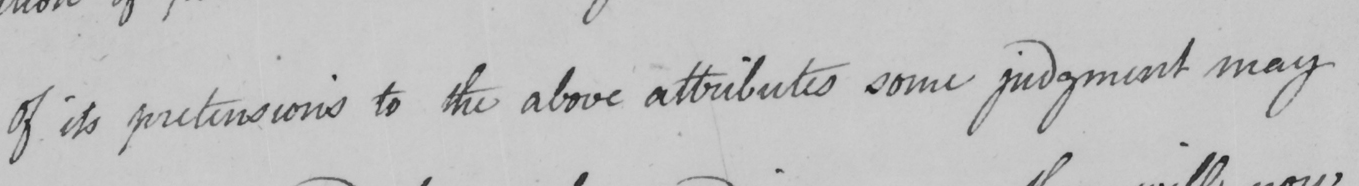Transcribe the text shown in this historical manuscript line. Of its pretensions to the above attributes some judgment may 